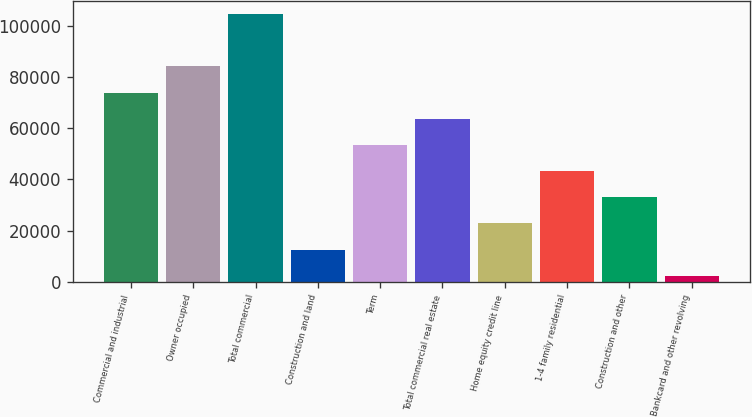<chart> <loc_0><loc_0><loc_500><loc_500><bar_chart><fcel>Commercial and industrial<fcel>Owner occupied<fcel>Total commercial<fcel>Construction and land<fcel>Term<fcel>Total commercial real estate<fcel>Home equity credit line<fcel>1-4 family residential<fcel>Construction and other<fcel>Bankcard and other revolving<nl><fcel>73871.2<fcel>84077.8<fcel>104491<fcel>12631.6<fcel>53458<fcel>63664.6<fcel>22838.2<fcel>43251.4<fcel>33044.8<fcel>2425<nl></chart> 